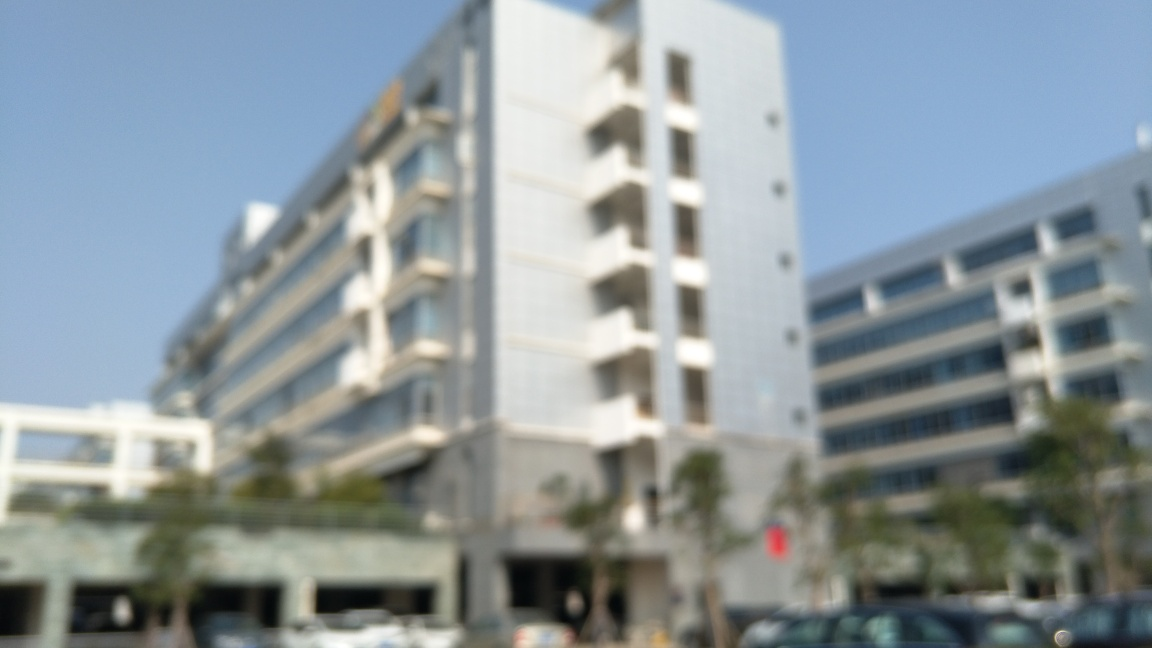Is there any text or signage visible in the image? The blurriness of the image prevents the identification of any text or signage, rendering such details indiscernible. 